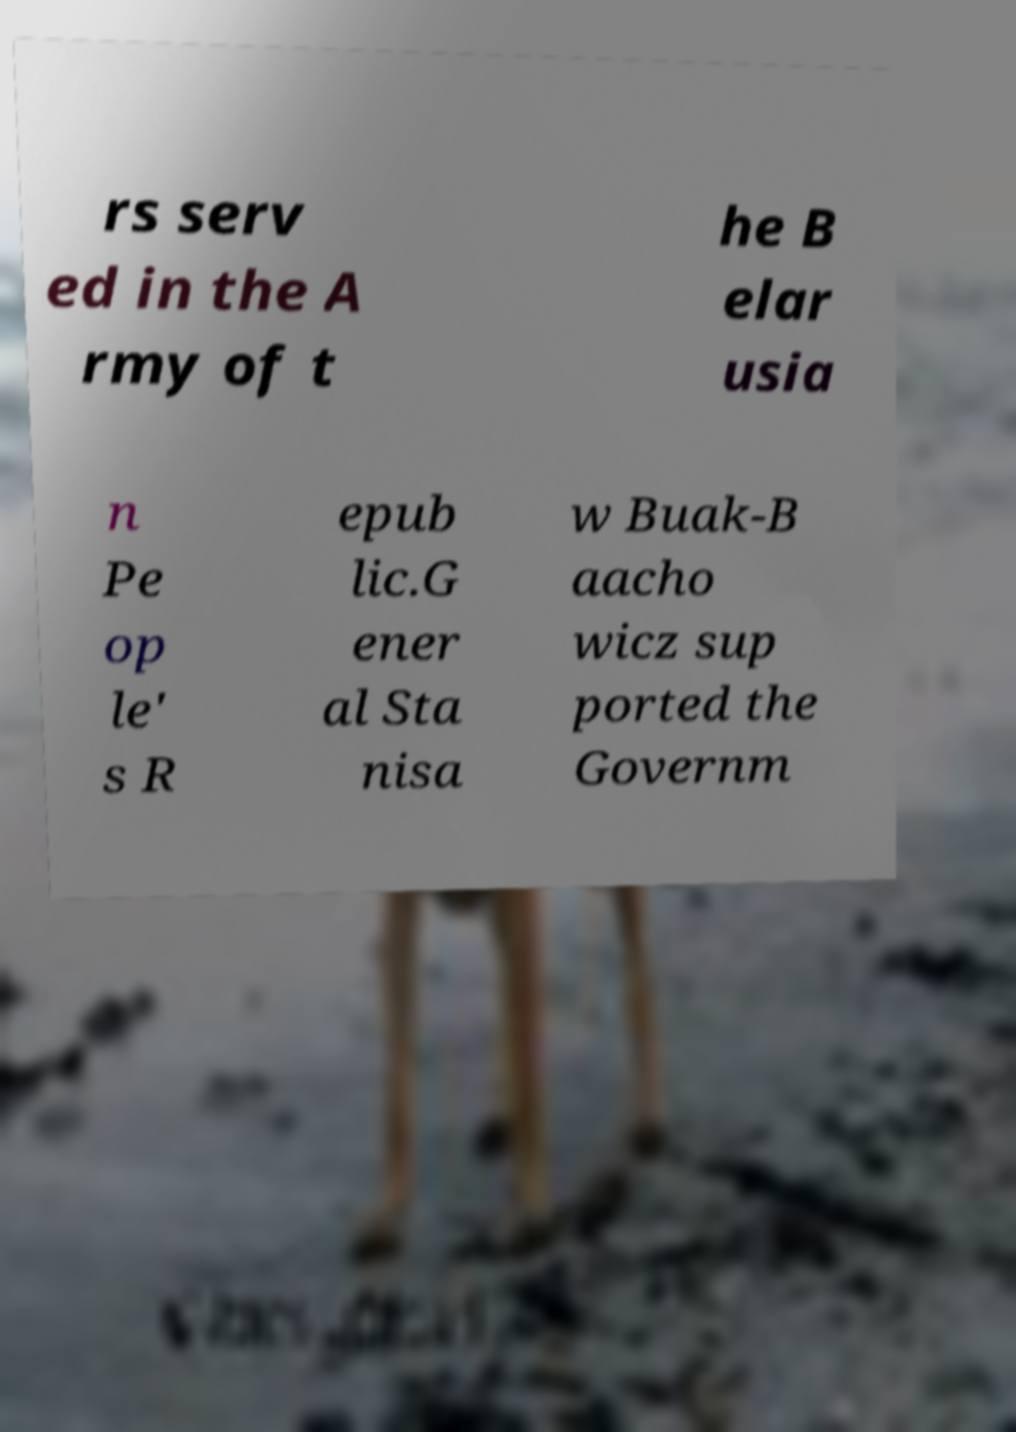Can you read and provide the text displayed in the image?This photo seems to have some interesting text. Can you extract and type it out for me? rs serv ed in the A rmy of t he B elar usia n Pe op le' s R epub lic.G ener al Sta nisa w Buak-B aacho wicz sup ported the Governm 